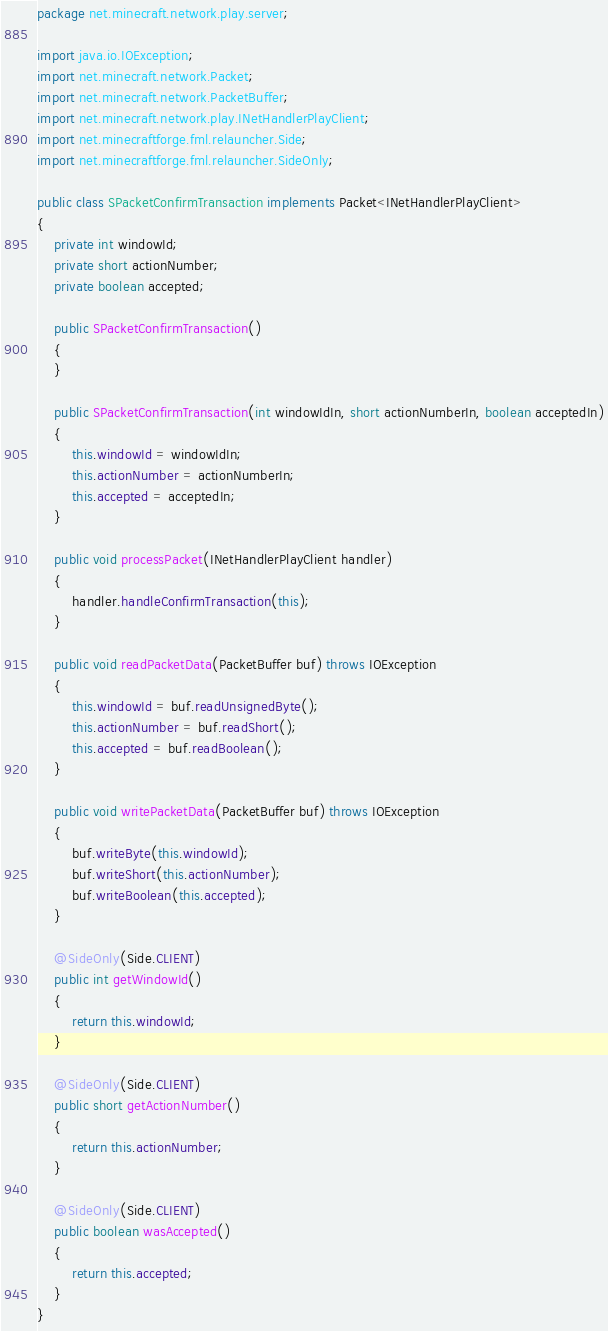<code> <loc_0><loc_0><loc_500><loc_500><_Java_>package net.minecraft.network.play.server;

import java.io.IOException;
import net.minecraft.network.Packet;
import net.minecraft.network.PacketBuffer;
import net.minecraft.network.play.INetHandlerPlayClient;
import net.minecraftforge.fml.relauncher.Side;
import net.minecraftforge.fml.relauncher.SideOnly;

public class SPacketConfirmTransaction implements Packet<INetHandlerPlayClient>
{
    private int windowId;
    private short actionNumber;
    private boolean accepted;

    public SPacketConfirmTransaction()
    {
    }

    public SPacketConfirmTransaction(int windowIdIn, short actionNumberIn, boolean acceptedIn)
    {
        this.windowId = windowIdIn;
        this.actionNumber = actionNumberIn;
        this.accepted = acceptedIn;
    }

    public void processPacket(INetHandlerPlayClient handler)
    {
        handler.handleConfirmTransaction(this);
    }

    public void readPacketData(PacketBuffer buf) throws IOException
    {
        this.windowId = buf.readUnsignedByte();
        this.actionNumber = buf.readShort();
        this.accepted = buf.readBoolean();
    }

    public void writePacketData(PacketBuffer buf) throws IOException
    {
        buf.writeByte(this.windowId);
        buf.writeShort(this.actionNumber);
        buf.writeBoolean(this.accepted);
    }

    @SideOnly(Side.CLIENT)
    public int getWindowId()
    {
        return this.windowId;
    }

    @SideOnly(Side.CLIENT)
    public short getActionNumber()
    {
        return this.actionNumber;
    }

    @SideOnly(Side.CLIENT)
    public boolean wasAccepted()
    {
        return this.accepted;
    }
}</code> 